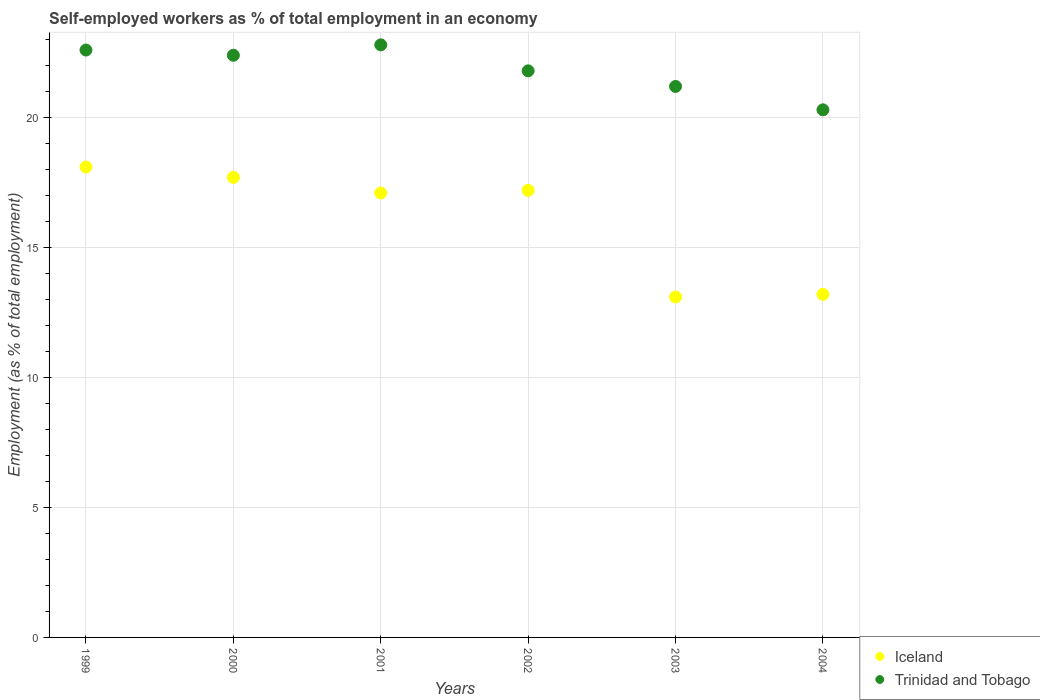How many different coloured dotlines are there?
Your answer should be compact. 2. What is the percentage of self-employed workers in Iceland in 1999?
Ensure brevity in your answer.  18.1. Across all years, what is the maximum percentage of self-employed workers in Iceland?
Offer a very short reply. 18.1. Across all years, what is the minimum percentage of self-employed workers in Iceland?
Offer a terse response. 13.1. In which year was the percentage of self-employed workers in Trinidad and Tobago maximum?
Give a very brief answer. 2001. In which year was the percentage of self-employed workers in Trinidad and Tobago minimum?
Give a very brief answer. 2004. What is the total percentage of self-employed workers in Iceland in the graph?
Provide a succinct answer. 96.4. What is the difference between the percentage of self-employed workers in Trinidad and Tobago in 2001 and that in 2002?
Your response must be concise. 1. What is the difference between the percentage of self-employed workers in Iceland in 2004 and the percentage of self-employed workers in Trinidad and Tobago in 2002?
Keep it short and to the point. -8.6. What is the average percentage of self-employed workers in Iceland per year?
Offer a terse response. 16.07. In the year 2000, what is the difference between the percentage of self-employed workers in Iceland and percentage of self-employed workers in Trinidad and Tobago?
Offer a very short reply. -4.7. What is the ratio of the percentage of self-employed workers in Trinidad and Tobago in 1999 to that in 2002?
Ensure brevity in your answer.  1.04. Is the percentage of self-employed workers in Trinidad and Tobago in 2000 less than that in 2004?
Keep it short and to the point. No. What is the difference between the highest and the second highest percentage of self-employed workers in Trinidad and Tobago?
Ensure brevity in your answer.  0.2. In how many years, is the percentage of self-employed workers in Iceland greater than the average percentage of self-employed workers in Iceland taken over all years?
Give a very brief answer. 4. Is the sum of the percentage of self-employed workers in Trinidad and Tobago in 2000 and 2004 greater than the maximum percentage of self-employed workers in Iceland across all years?
Offer a terse response. Yes. Does the percentage of self-employed workers in Trinidad and Tobago monotonically increase over the years?
Provide a succinct answer. No. Does the graph contain grids?
Offer a terse response. Yes. Where does the legend appear in the graph?
Provide a succinct answer. Bottom right. How are the legend labels stacked?
Give a very brief answer. Vertical. What is the title of the graph?
Offer a very short reply. Self-employed workers as % of total employment in an economy. Does "Greece" appear as one of the legend labels in the graph?
Provide a short and direct response. No. What is the label or title of the X-axis?
Your response must be concise. Years. What is the label or title of the Y-axis?
Give a very brief answer. Employment (as % of total employment). What is the Employment (as % of total employment) of Iceland in 1999?
Your answer should be compact. 18.1. What is the Employment (as % of total employment) in Trinidad and Tobago in 1999?
Your answer should be compact. 22.6. What is the Employment (as % of total employment) in Iceland in 2000?
Keep it short and to the point. 17.7. What is the Employment (as % of total employment) in Trinidad and Tobago in 2000?
Ensure brevity in your answer.  22.4. What is the Employment (as % of total employment) in Iceland in 2001?
Offer a very short reply. 17.1. What is the Employment (as % of total employment) of Trinidad and Tobago in 2001?
Your response must be concise. 22.8. What is the Employment (as % of total employment) in Iceland in 2002?
Ensure brevity in your answer.  17.2. What is the Employment (as % of total employment) of Trinidad and Tobago in 2002?
Provide a succinct answer. 21.8. What is the Employment (as % of total employment) of Iceland in 2003?
Make the answer very short. 13.1. What is the Employment (as % of total employment) in Trinidad and Tobago in 2003?
Your answer should be very brief. 21.2. What is the Employment (as % of total employment) in Iceland in 2004?
Give a very brief answer. 13.2. What is the Employment (as % of total employment) of Trinidad and Tobago in 2004?
Offer a very short reply. 20.3. Across all years, what is the maximum Employment (as % of total employment) in Iceland?
Provide a short and direct response. 18.1. Across all years, what is the maximum Employment (as % of total employment) of Trinidad and Tobago?
Make the answer very short. 22.8. Across all years, what is the minimum Employment (as % of total employment) of Iceland?
Your answer should be very brief. 13.1. Across all years, what is the minimum Employment (as % of total employment) in Trinidad and Tobago?
Provide a succinct answer. 20.3. What is the total Employment (as % of total employment) in Iceland in the graph?
Ensure brevity in your answer.  96.4. What is the total Employment (as % of total employment) of Trinidad and Tobago in the graph?
Your answer should be compact. 131.1. What is the difference between the Employment (as % of total employment) of Iceland in 1999 and that in 2000?
Your answer should be compact. 0.4. What is the difference between the Employment (as % of total employment) of Iceland in 1999 and that in 2001?
Keep it short and to the point. 1. What is the difference between the Employment (as % of total employment) of Iceland in 1999 and that in 2002?
Offer a very short reply. 0.9. What is the difference between the Employment (as % of total employment) of Trinidad and Tobago in 1999 and that in 2002?
Make the answer very short. 0.8. What is the difference between the Employment (as % of total employment) in Trinidad and Tobago in 1999 and that in 2003?
Your response must be concise. 1.4. What is the difference between the Employment (as % of total employment) of Iceland in 2000 and that in 2001?
Give a very brief answer. 0.6. What is the difference between the Employment (as % of total employment) of Trinidad and Tobago in 2000 and that in 2003?
Give a very brief answer. 1.2. What is the difference between the Employment (as % of total employment) in Iceland in 2000 and that in 2004?
Keep it short and to the point. 4.5. What is the difference between the Employment (as % of total employment) of Trinidad and Tobago in 2000 and that in 2004?
Provide a succinct answer. 2.1. What is the difference between the Employment (as % of total employment) in Trinidad and Tobago in 2001 and that in 2002?
Provide a succinct answer. 1. What is the difference between the Employment (as % of total employment) in Iceland in 2001 and that in 2003?
Offer a very short reply. 4. What is the difference between the Employment (as % of total employment) in Trinidad and Tobago in 2001 and that in 2003?
Ensure brevity in your answer.  1.6. What is the difference between the Employment (as % of total employment) of Iceland in 2001 and that in 2004?
Your answer should be very brief. 3.9. What is the difference between the Employment (as % of total employment) of Trinidad and Tobago in 2001 and that in 2004?
Your answer should be compact. 2.5. What is the difference between the Employment (as % of total employment) of Iceland in 2002 and that in 2003?
Provide a short and direct response. 4.1. What is the difference between the Employment (as % of total employment) of Trinidad and Tobago in 2002 and that in 2003?
Provide a short and direct response. 0.6. What is the difference between the Employment (as % of total employment) in Trinidad and Tobago in 2002 and that in 2004?
Offer a very short reply. 1.5. What is the difference between the Employment (as % of total employment) of Iceland in 2003 and that in 2004?
Offer a very short reply. -0.1. What is the difference between the Employment (as % of total employment) of Trinidad and Tobago in 2003 and that in 2004?
Offer a terse response. 0.9. What is the difference between the Employment (as % of total employment) of Iceland in 1999 and the Employment (as % of total employment) of Trinidad and Tobago in 2000?
Provide a short and direct response. -4.3. What is the difference between the Employment (as % of total employment) of Iceland in 1999 and the Employment (as % of total employment) of Trinidad and Tobago in 2001?
Your response must be concise. -4.7. What is the difference between the Employment (as % of total employment) in Iceland in 1999 and the Employment (as % of total employment) in Trinidad and Tobago in 2003?
Offer a terse response. -3.1. What is the difference between the Employment (as % of total employment) in Iceland in 2000 and the Employment (as % of total employment) in Trinidad and Tobago in 2001?
Provide a succinct answer. -5.1. What is the difference between the Employment (as % of total employment) in Iceland in 2000 and the Employment (as % of total employment) in Trinidad and Tobago in 2002?
Keep it short and to the point. -4.1. What is the difference between the Employment (as % of total employment) of Iceland in 2000 and the Employment (as % of total employment) of Trinidad and Tobago in 2003?
Provide a short and direct response. -3.5. What is the difference between the Employment (as % of total employment) of Iceland in 2001 and the Employment (as % of total employment) of Trinidad and Tobago in 2003?
Your response must be concise. -4.1. What is the average Employment (as % of total employment) in Iceland per year?
Provide a succinct answer. 16.07. What is the average Employment (as % of total employment) of Trinidad and Tobago per year?
Your answer should be very brief. 21.85. In the year 1999, what is the difference between the Employment (as % of total employment) of Iceland and Employment (as % of total employment) of Trinidad and Tobago?
Give a very brief answer. -4.5. In the year 2000, what is the difference between the Employment (as % of total employment) in Iceland and Employment (as % of total employment) in Trinidad and Tobago?
Give a very brief answer. -4.7. In the year 2001, what is the difference between the Employment (as % of total employment) in Iceland and Employment (as % of total employment) in Trinidad and Tobago?
Your answer should be compact. -5.7. In the year 2003, what is the difference between the Employment (as % of total employment) in Iceland and Employment (as % of total employment) in Trinidad and Tobago?
Provide a short and direct response. -8.1. In the year 2004, what is the difference between the Employment (as % of total employment) of Iceland and Employment (as % of total employment) of Trinidad and Tobago?
Give a very brief answer. -7.1. What is the ratio of the Employment (as % of total employment) in Iceland in 1999 to that in 2000?
Your answer should be compact. 1.02. What is the ratio of the Employment (as % of total employment) of Trinidad and Tobago in 1999 to that in 2000?
Provide a succinct answer. 1.01. What is the ratio of the Employment (as % of total employment) of Iceland in 1999 to that in 2001?
Your response must be concise. 1.06. What is the ratio of the Employment (as % of total employment) of Iceland in 1999 to that in 2002?
Make the answer very short. 1.05. What is the ratio of the Employment (as % of total employment) of Trinidad and Tobago in 1999 to that in 2002?
Keep it short and to the point. 1.04. What is the ratio of the Employment (as % of total employment) in Iceland in 1999 to that in 2003?
Ensure brevity in your answer.  1.38. What is the ratio of the Employment (as % of total employment) in Trinidad and Tobago in 1999 to that in 2003?
Your answer should be compact. 1.07. What is the ratio of the Employment (as % of total employment) of Iceland in 1999 to that in 2004?
Provide a short and direct response. 1.37. What is the ratio of the Employment (as % of total employment) in Trinidad and Tobago in 1999 to that in 2004?
Provide a succinct answer. 1.11. What is the ratio of the Employment (as % of total employment) of Iceland in 2000 to that in 2001?
Offer a very short reply. 1.04. What is the ratio of the Employment (as % of total employment) in Trinidad and Tobago in 2000 to that in 2001?
Provide a succinct answer. 0.98. What is the ratio of the Employment (as % of total employment) of Iceland in 2000 to that in 2002?
Your response must be concise. 1.03. What is the ratio of the Employment (as % of total employment) of Trinidad and Tobago in 2000 to that in 2002?
Offer a very short reply. 1.03. What is the ratio of the Employment (as % of total employment) of Iceland in 2000 to that in 2003?
Offer a very short reply. 1.35. What is the ratio of the Employment (as % of total employment) in Trinidad and Tobago in 2000 to that in 2003?
Your response must be concise. 1.06. What is the ratio of the Employment (as % of total employment) of Iceland in 2000 to that in 2004?
Offer a terse response. 1.34. What is the ratio of the Employment (as % of total employment) of Trinidad and Tobago in 2000 to that in 2004?
Give a very brief answer. 1.1. What is the ratio of the Employment (as % of total employment) of Iceland in 2001 to that in 2002?
Your answer should be compact. 0.99. What is the ratio of the Employment (as % of total employment) of Trinidad and Tobago in 2001 to that in 2002?
Make the answer very short. 1.05. What is the ratio of the Employment (as % of total employment) of Iceland in 2001 to that in 2003?
Offer a terse response. 1.31. What is the ratio of the Employment (as % of total employment) in Trinidad and Tobago in 2001 to that in 2003?
Ensure brevity in your answer.  1.08. What is the ratio of the Employment (as % of total employment) of Iceland in 2001 to that in 2004?
Provide a succinct answer. 1.3. What is the ratio of the Employment (as % of total employment) in Trinidad and Tobago in 2001 to that in 2004?
Offer a very short reply. 1.12. What is the ratio of the Employment (as % of total employment) of Iceland in 2002 to that in 2003?
Your answer should be compact. 1.31. What is the ratio of the Employment (as % of total employment) in Trinidad and Tobago in 2002 to that in 2003?
Your answer should be compact. 1.03. What is the ratio of the Employment (as % of total employment) of Iceland in 2002 to that in 2004?
Keep it short and to the point. 1.3. What is the ratio of the Employment (as % of total employment) of Trinidad and Tobago in 2002 to that in 2004?
Keep it short and to the point. 1.07. What is the ratio of the Employment (as % of total employment) of Trinidad and Tobago in 2003 to that in 2004?
Offer a very short reply. 1.04. What is the difference between the highest and the second highest Employment (as % of total employment) of Iceland?
Offer a very short reply. 0.4. What is the difference between the highest and the lowest Employment (as % of total employment) of Iceland?
Offer a very short reply. 5. 